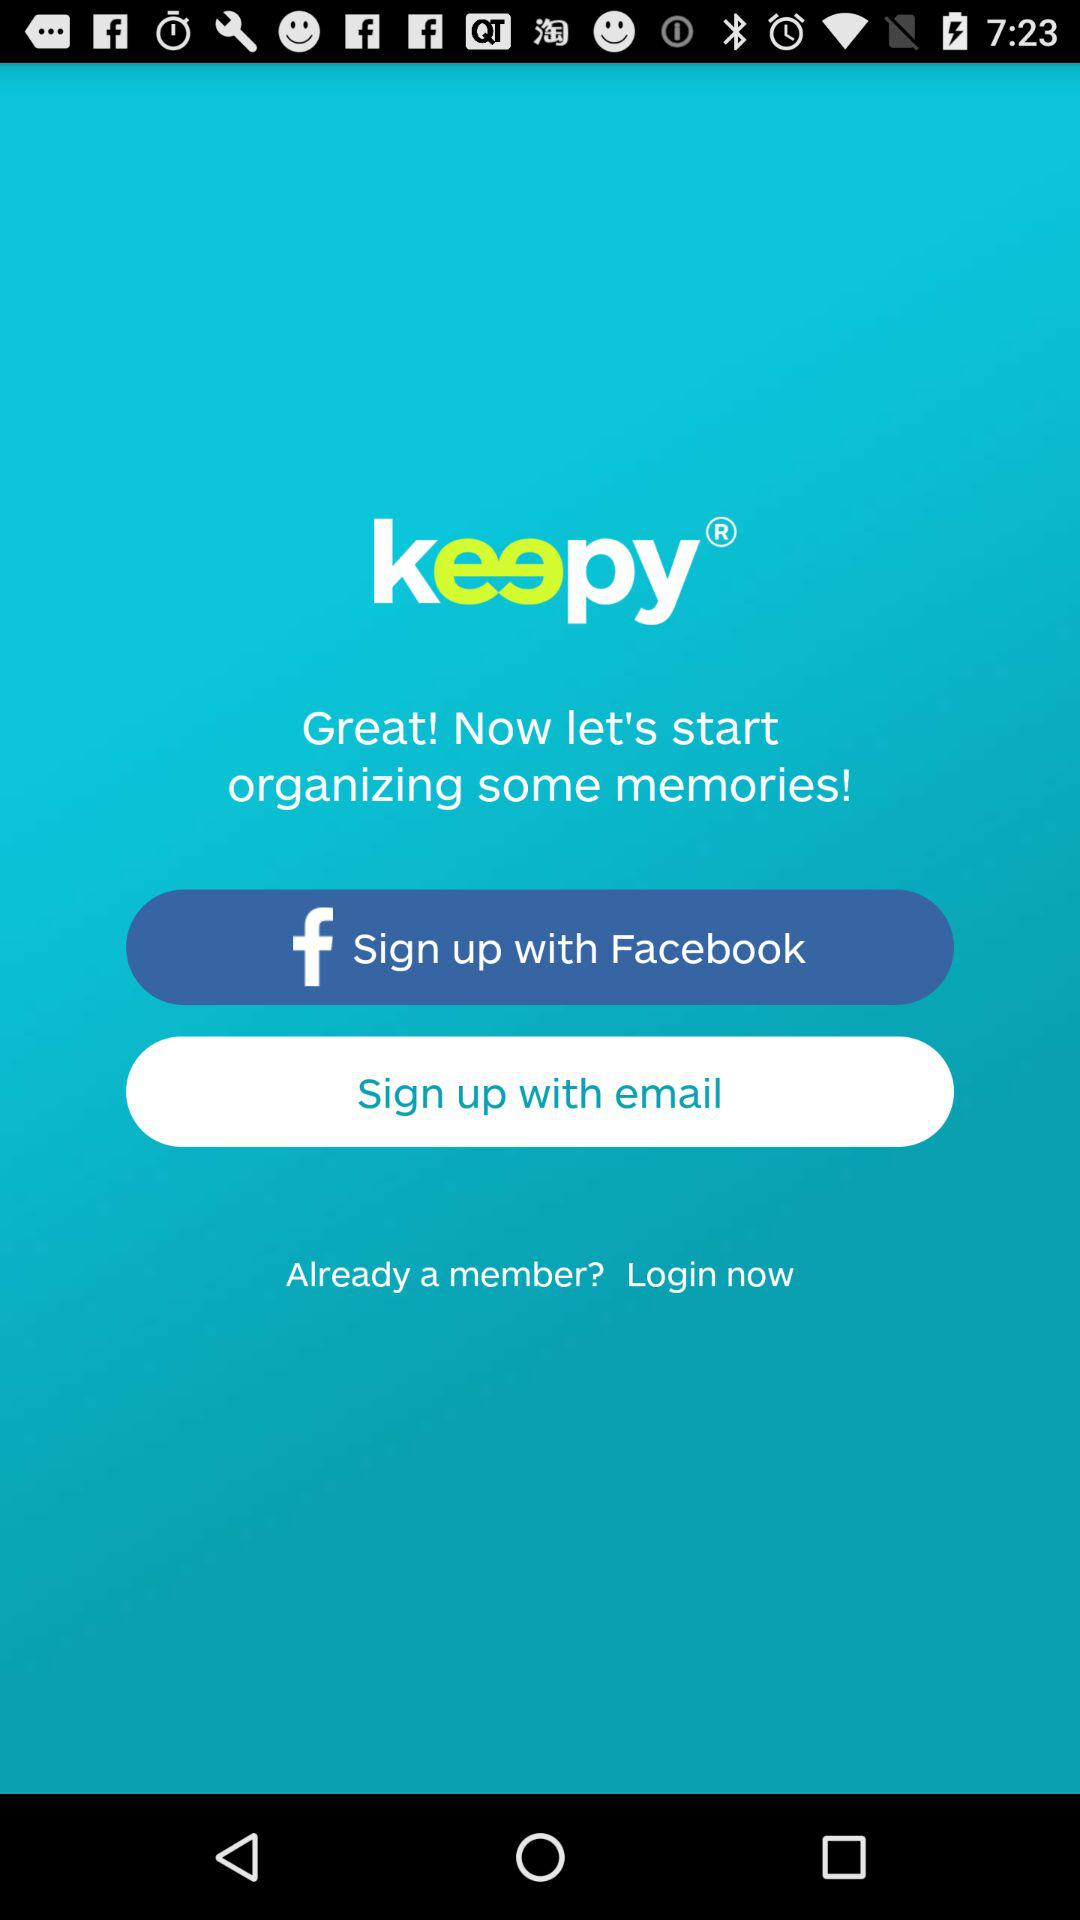What are the different sign-up options? The different sign up options are "Facebook" and "email". 